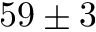<formula> <loc_0><loc_0><loc_500><loc_500>5 9 \pm 3</formula> 